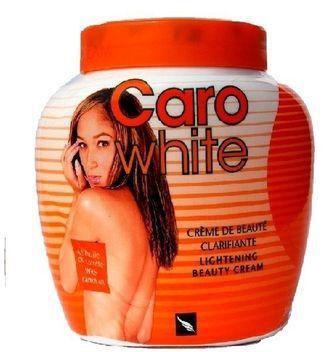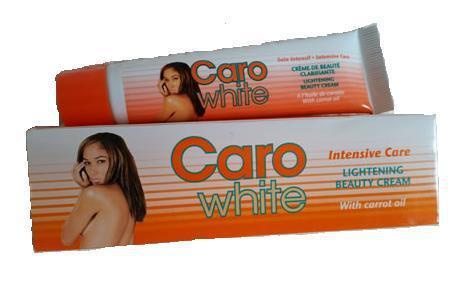The first image is the image on the left, the second image is the image on the right. Evaluate the accuracy of this statement regarding the images: "One product is sitting on its box.". Is it true? Answer yes or no. Yes. The first image is the image on the left, the second image is the image on the right. For the images displayed, is the sentence "Each image includes a squat, roundish jar with a flat orange lid, and at least one image also includes a cylinder-shaped bottle and orange cap, and a bottle with a blue cap." factually correct? Answer yes or no. No. 